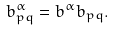<formula> <loc_0><loc_0><loc_500><loc_500>b _ { p q } ^ { \alpha } = b ^ { \alpha } b _ { p q } .</formula> 